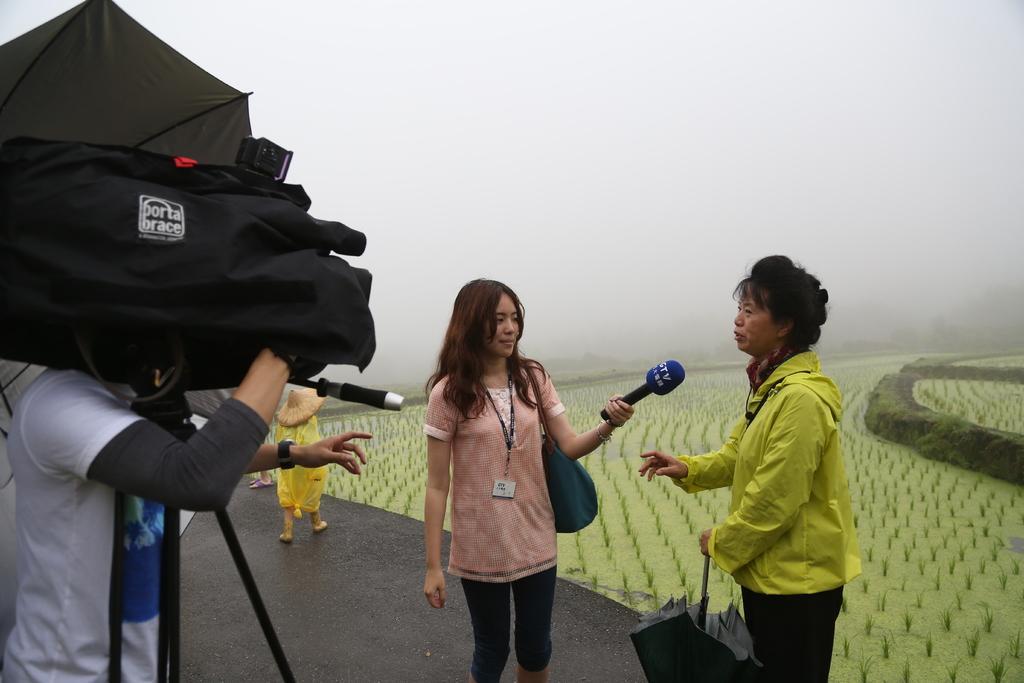Describe this image in one or two sentences. In the image the woman is interviewing another woman standing in front of her and on the left side another person is capturing the video of them, in the background there are beautiful crops. 